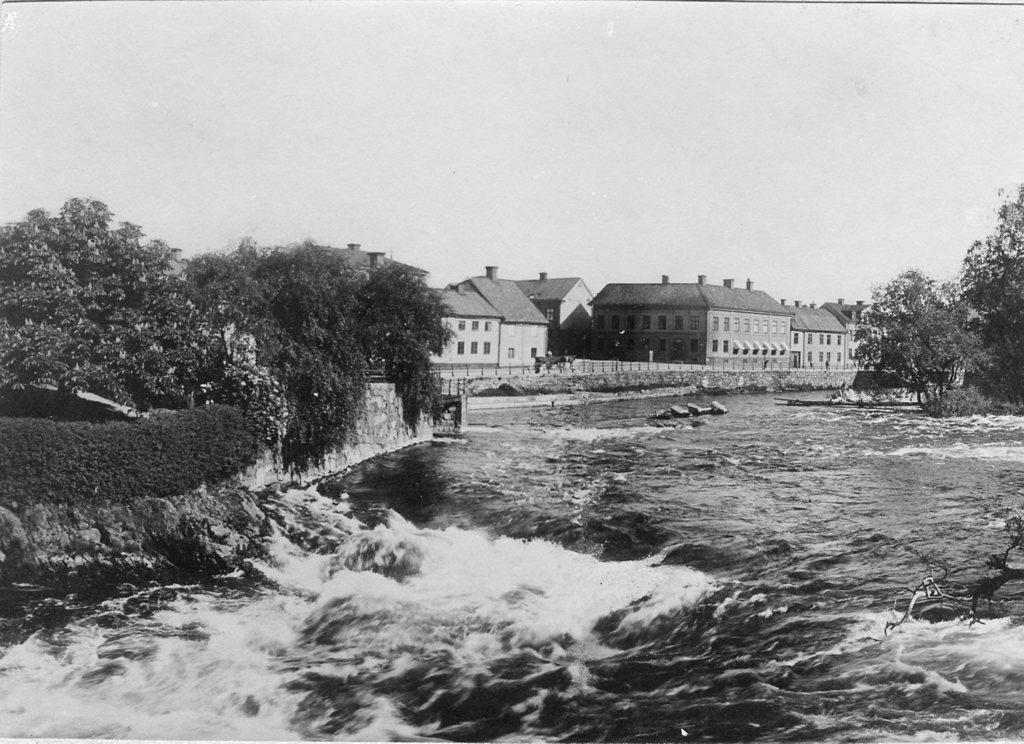What is the primary element visible in the image? There is water in the image. What type of vegetation can be seen in the image? There are trees in the image. What type of structure is present in the image? There is a wall in the image. What type of man-made structures are visible in the image? There are buildings in the image. What can be seen in the background of the image? The sky is visible in the background of the image. What is the color scheme of the image? The image is black and white in color. How many cattle are grazing in the image? There are no cattle present in the image. What type of crown is worn by the person in the image? There is no person or crown present in the image. 